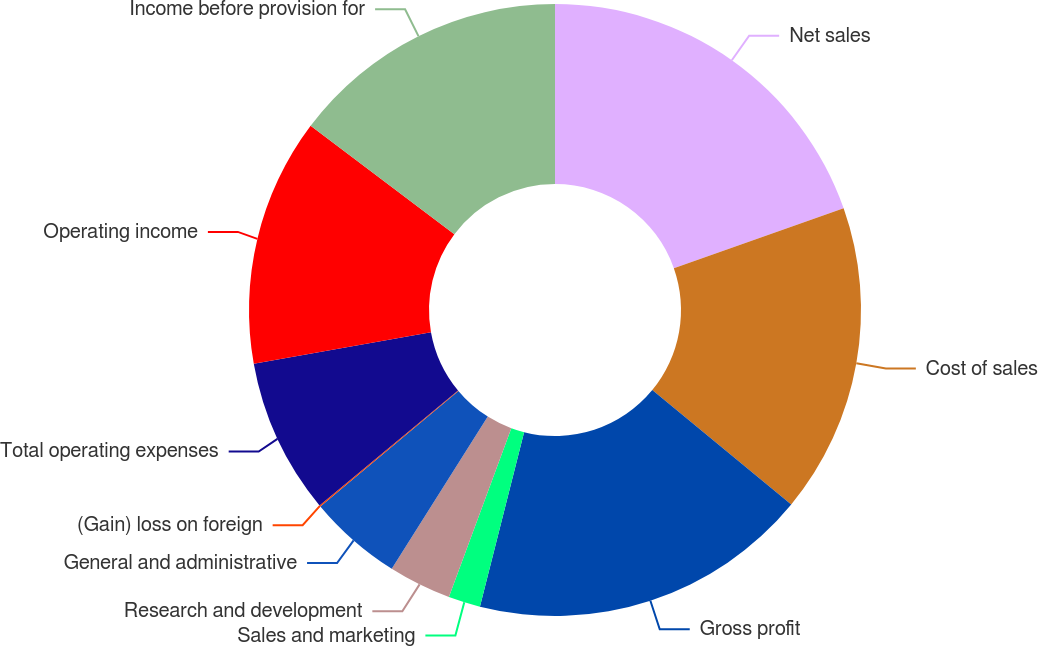<chart> <loc_0><loc_0><loc_500><loc_500><pie_chart><fcel>Net sales<fcel>Cost of sales<fcel>Gross profit<fcel>Sales and marketing<fcel>Research and development<fcel>General and administrative<fcel>(Gain) loss on foreign<fcel>Total operating expenses<fcel>Operating income<fcel>Income before provision for<nl><fcel>19.61%<fcel>16.35%<fcel>17.98%<fcel>1.69%<fcel>3.32%<fcel>4.95%<fcel>0.07%<fcel>8.21%<fcel>13.09%<fcel>14.72%<nl></chart> 